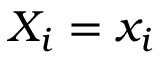<formula> <loc_0><loc_0><loc_500><loc_500>X _ { i } = x _ { i }</formula> 